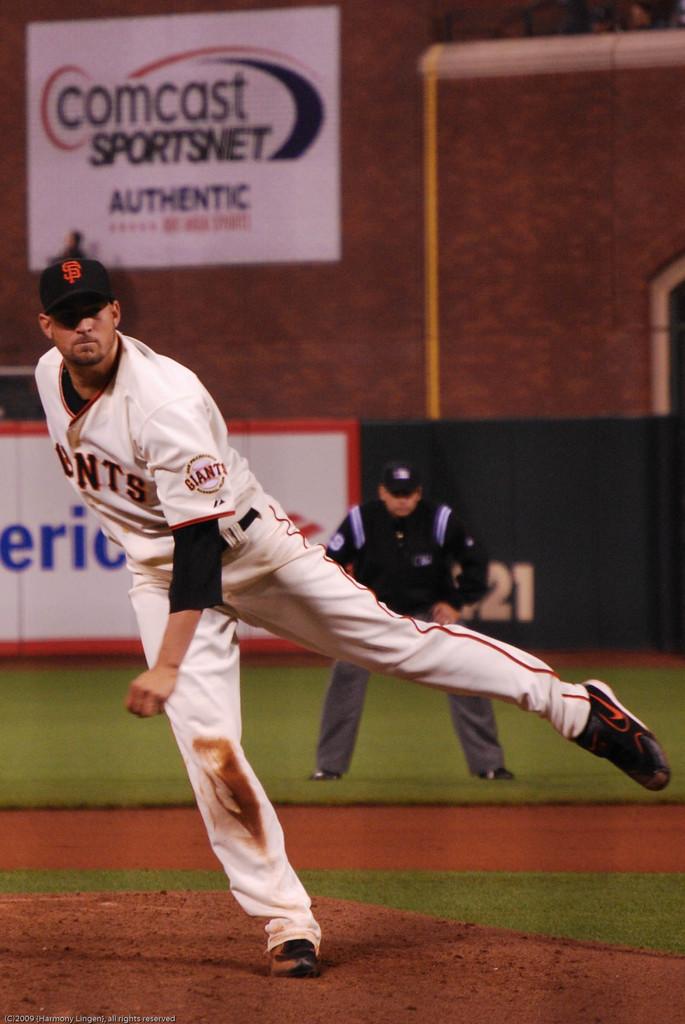Who is the sponsor for sportsnet?
Ensure brevity in your answer.  Comcast. Who is comcast sponsoring?
Give a very brief answer. Sportsnet. 